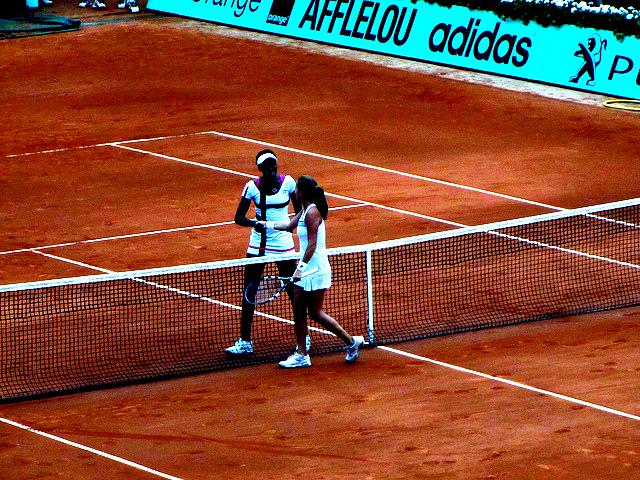What is the main activity taking place in this image? The main activity in the image is a tennis match, possibly a doubles game given that there are two players standing together at the net which is a common sight during a doubles match when strategizing or celebrating a point. 